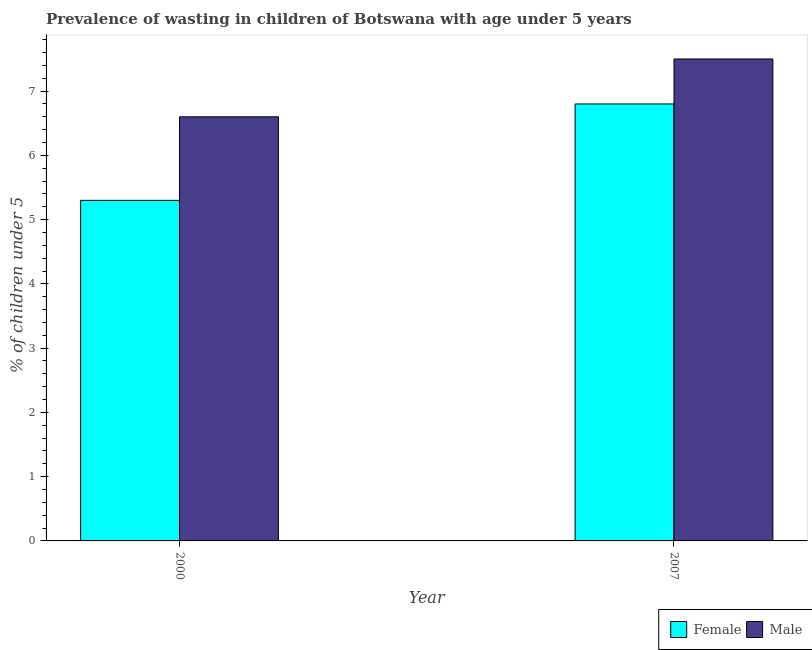How many groups of bars are there?
Give a very brief answer. 2. Are the number of bars per tick equal to the number of legend labels?
Your response must be concise. Yes. How many bars are there on the 1st tick from the left?
Offer a very short reply. 2. How many bars are there on the 2nd tick from the right?
Make the answer very short. 2. In how many cases, is the number of bars for a given year not equal to the number of legend labels?
Provide a short and direct response. 0. What is the percentage of undernourished female children in 2007?
Provide a short and direct response. 6.8. Across all years, what is the minimum percentage of undernourished female children?
Your answer should be compact. 5.3. In which year was the percentage of undernourished male children maximum?
Provide a succinct answer. 2007. What is the total percentage of undernourished female children in the graph?
Your answer should be compact. 12.1. What is the difference between the percentage of undernourished male children in 2000 and that in 2007?
Offer a very short reply. -0.9. What is the difference between the percentage of undernourished male children in 2000 and the percentage of undernourished female children in 2007?
Offer a terse response. -0.9. What is the average percentage of undernourished female children per year?
Give a very brief answer. 6.05. In how many years, is the percentage of undernourished male children greater than 1.4 %?
Your response must be concise. 2. What is the ratio of the percentage of undernourished male children in 2000 to that in 2007?
Offer a terse response. 0.88. What does the 2nd bar from the right in 2007 represents?
Give a very brief answer. Female. How many years are there in the graph?
Keep it short and to the point. 2. What is the difference between two consecutive major ticks on the Y-axis?
Ensure brevity in your answer.  1. Are the values on the major ticks of Y-axis written in scientific E-notation?
Provide a short and direct response. No. Does the graph contain grids?
Make the answer very short. No. Where does the legend appear in the graph?
Keep it short and to the point. Bottom right. What is the title of the graph?
Give a very brief answer. Prevalence of wasting in children of Botswana with age under 5 years. Does "Primary" appear as one of the legend labels in the graph?
Give a very brief answer. No. What is the label or title of the Y-axis?
Make the answer very short.  % of children under 5. What is the  % of children under 5 in Female in 2000?
Your answer should be very brief. 5.3. What is the  % of children under 5 in Male in 2000?
Offer a terse response. 6.6. What is the  % of children under 5 of Female in 2007?
Provide a succinct answer. 6.8. What is the  % of children under 5 of Male in 2007?
Provide a succinct answer. 7.5. Across all years, what is the maximum  % of children under 5 in Female?
Your response must be concise. 6.8. Across all years, what is the minimum  % of children under 5 in Female?
Offer a terse response. 5.3. Across all years, what is the minimum  % of children under 5 in Male?
Provide a short and direct response. 6.6. What is the total  % of children under 5 of Female in the graph?
Offer a very short reply. 12.1. What is the difference between the  % of children under 5 of Female in 2000 and that in 2007?
Keep it short and to the point. -1.5. What is the difference between the  % of children under 5 of Male in 2000 and that in 2007?
Provide a succinct answer. -0.9. What is the difference between the  % of children under 5 in Female in 2000 and the  % of children under 5 in Male in 2007?
Ensure brevity in your answer.  -2.2. What is the average  % of children under 5 of Female per year?
Your answer should be very brief. 6.05. What is the average  % of children under 5 in Male per year?
Your answer should be compact. 7.05. In the year 2007, what is the difference between the  % of children under 5 of Female and  % of children under 5 of Male?
Give a very brief answer. -0.7. What is the ratio of the  % of children under 5 in Female in 2000 to that in 2007?
Make the answer very short. 0.78. What is the ratio of the  % of children under 5 in Male in 2000 to that in 2007?
Your answer should be very brief. 0.88. What is the difference between the highest and the second highest  % of children under 5 in Female?
Make the answer very short. 1.5. 